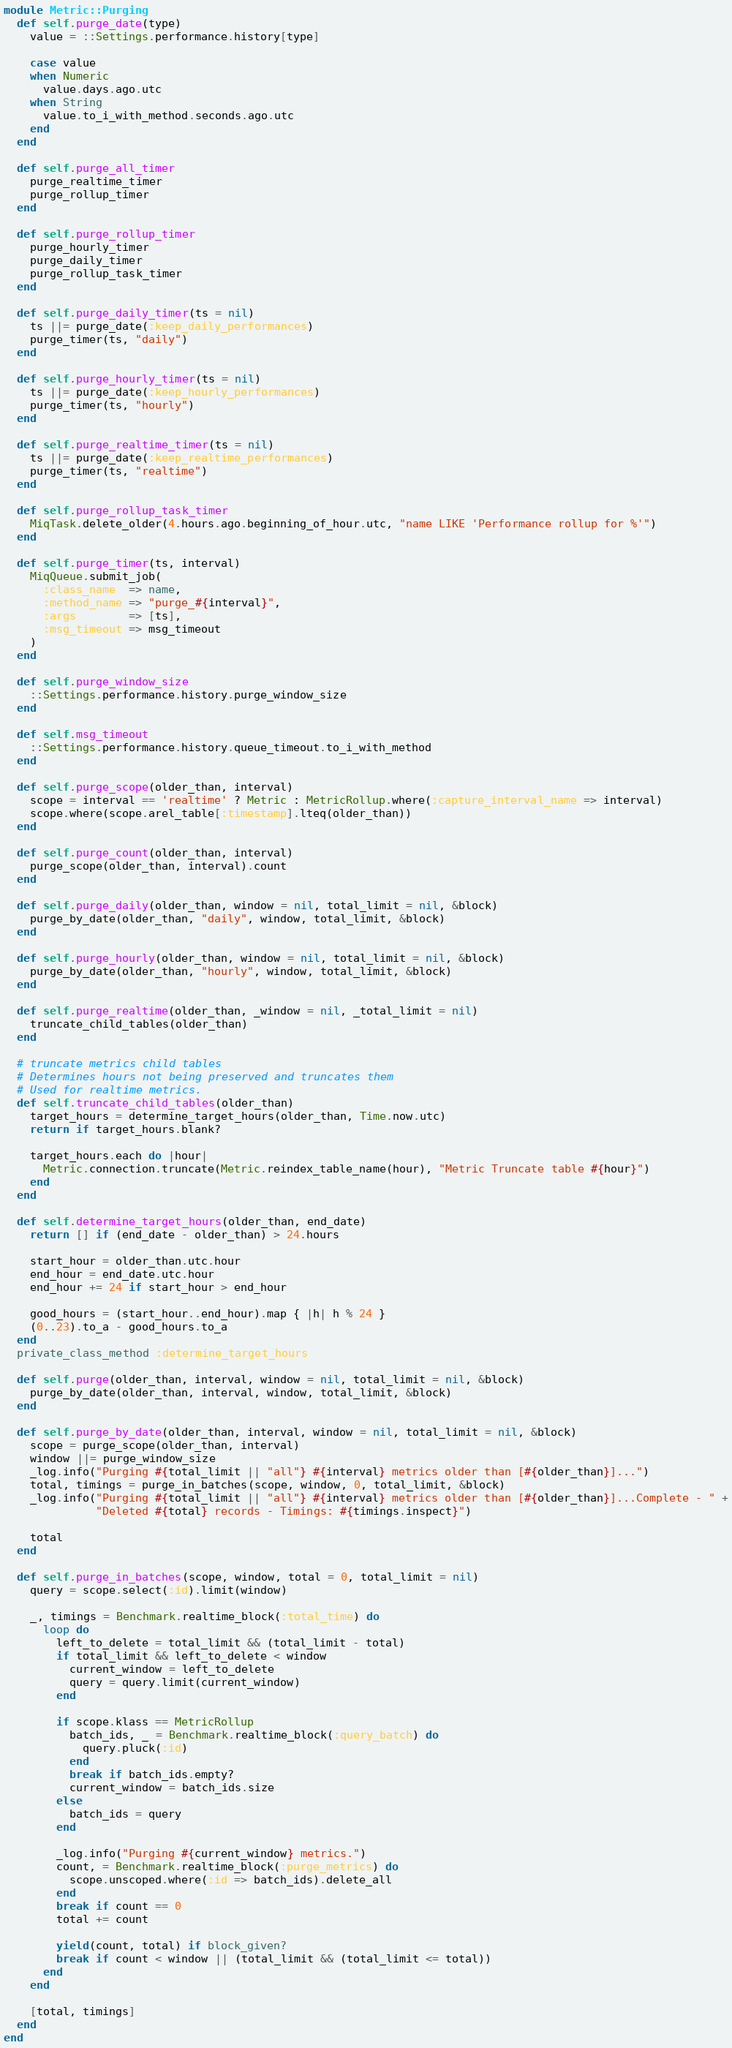Convert code to text. <code><loc_0><loc_0><loc_500><loc_500><_Ruby_>module Metric::Purging
  def self.purge_date(type)
    value = ::Settings.performance.history[type]

    case value
    when Numeric
      value.days.ago.utc
    when String
      value.to_i_with_method.seconds.ago.utc
    end
  end

  def self.purge_all_timer
    purge_realtime_timer
    purge_rollup_timer
  end

  def self.purge_rollup_timer
    purge_hourly_timer
    purge_daily_timer
    purge_rollup_task_timer
  end

  def self.purge_daily_timer(ts = nil)
    ts ||= purge_date(:keep_daily_performances)
    purge_timer(ts, "daily")
  end

  def self.purge_hourly_timer(ts = nil)
    ts ||= purge_date(:keep_hourly_performances)
    purge_timer(ts, "hourly")
  end

  def self.purge_realtime_timer(ts = nil)
    ts ||= purge_date(:keep_realtime_performances)
    purge_timer(ts, "realtime")
  end

  def self.purge_rollup_task_timer
    MiqTask.delete_older(4.hours.ago.beginning_of_hour.utc, "name LIKE 'Performance rollup for %'")
  end

  def self.purge_timer(ts, interval)
    MiqQueue.submit_job(
      :class_name  => name,
      :method_name => "purge_#{interval}",
      :args        => [ts],
      :msg_timeout => msg_timeout
    )
  end

  def self.purge_window_size
    ::Settings.performance.history.purge_window_size
  end

  def self.msg_timeout
    ::Settings.performance.history.queue_timeout.to_i_with_method
  end

  def self.purge_scope(older_than, interval)
    scope = interval == 'realtime' ? Metric : MetricRollup.where(:capture_interval_name => interval)
    scope.where(scope.arel_table[:timestamp].lteq(older_than))
  end

  def self.purge_count(older_than, interval)
    purge_scope(older_than, interval).count
  end

  def self.purge_daily(older_than, window = nil, total_limit = nil, &block)
    purge_by_date(older_than, "daily", window, total_limit, &block)
  end

  def self.purge_hourly(older_than, window = nil, total_limit = nil, &block)
    purge_by_date(older_than, "hourly", window, total_limit, &block)
  end

  def self.purge_realtime(older_than, _window = nil, _total_limit = nil)
    truncate_child_tables(older_than)
  end

  # truncate metrics child tables
  # Determines hours not being preserved and truncates them
  # Used for realtime metrics.
  def self.truncate_child_tables(older_than)
    target_hours = determine_target_hours(older_than, Time.now.utc)
    return if target_hours.blank?

    target_hours.each do |hour|
      Metric.connection.truncate(Metric.reindex_table_name(hour), "Metric Truncate table #{hour}")
    end
  end

  def self.determine_target_hours(older_than, end_date)
    return [] if (end_date - older_than) > 24.hours

    start_hour = older_than.utc.hour
    end_hour = end_date.utc.hour
    end_hour += 24 if start_hour > end_hour

    good_hours = (start_hour..end_hour).map { |h| h % 24 }
    (0..23).to_a - good_hours.to_a
  end
  private_class_method :determine_target_hours

  def self.purge(older_than, interval, window = nil, total_limit = nil, &block)
    purge_by_date(older_than, interval, window, total_limit, &block)
  end

  def self.purge_by_date(older_than, interval, window = nil, total_limit = nil, &block)
    scope = purge_scope(older_than, interval)
    window ||= purge_window_size
    _log.info("Purging #{total_limit || "all"} #{interval} metrics older than [#{older_than}]...")
    total, timings = purge_in_batches(scope, window, 0, total_limit, &block)
    _log.info("Purging #{total_limit || "all"} #{interval} metrics older than [#{older_than}]...Complete - " +
              "Deleted #{total} records - Timings: #{timings.inspect}")

    total
  end

  def self.purge_in_batches(scope, window, total = 0, total_limit = nil)
    query = scope.select(:id).limit(window)

    _, timings = Benchmark.realtime_block(:total_time) do
      loop do
        left_to_delete = total_limit && (total_limit - total)
        if total_limit && left_to_delete < window
          current_window = left_to_delete
          query = query.limit(current_window)
        end

        if scope.klass == MetricRollup
          batch_ids, _ = Benchmark.realtime_block(:query_batch) do
            query.pluck(:id)
          end
          break if batch_ids.empty?
          current_window = batch_ids.size
        else
          batch_ids = query
        end

        _log.info("Purging #{current_window} metrics.")
        count, = Benchmark.realtime_block(:purge_metrics) do
          scope.unscoped.where(:id => batch_ids).delete_all
        end
        break if count == 0
        total += count

        yield(count, total) if block_given?
        break if count < window || (total_limit && (total_limit <= total))
      end
    end

    [total, timings]
  end
end
</code> 